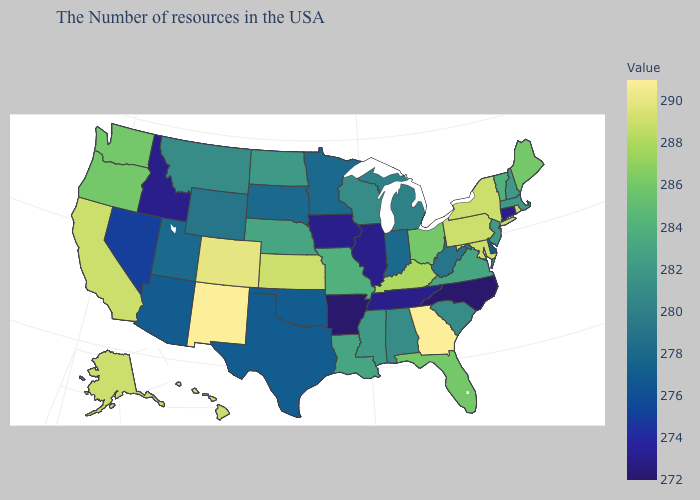Which states have the lowest value in the USA?
Give a very brief answer. North Carolina, Arkansas. Among the states that border West Virginia , does Pennsylvania have the highest value?
Keep it brief. Yes. 